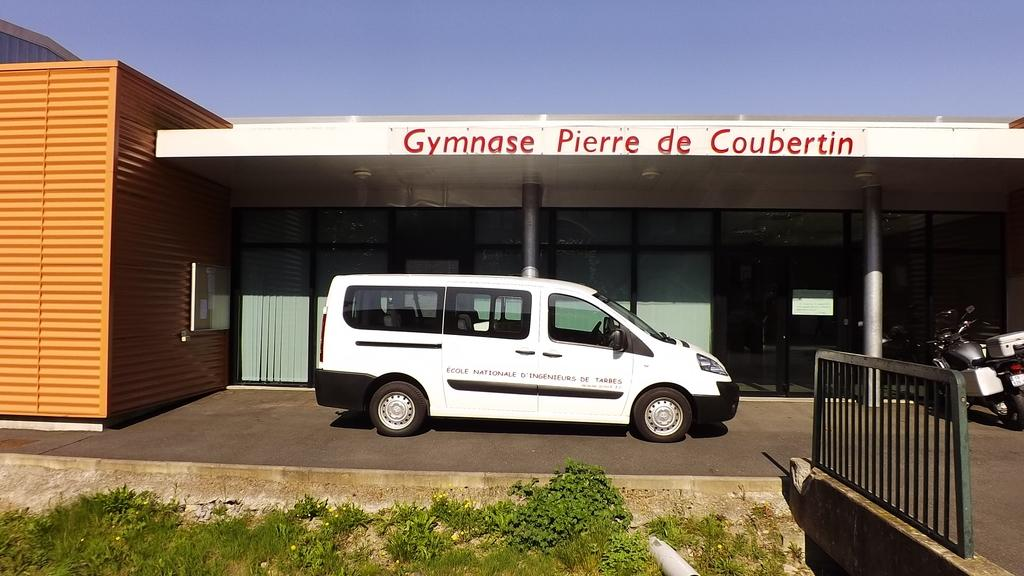<image>
Describe the image concisely. A white van is parked below a building that says Gymnase Pierre de Coubertin. 